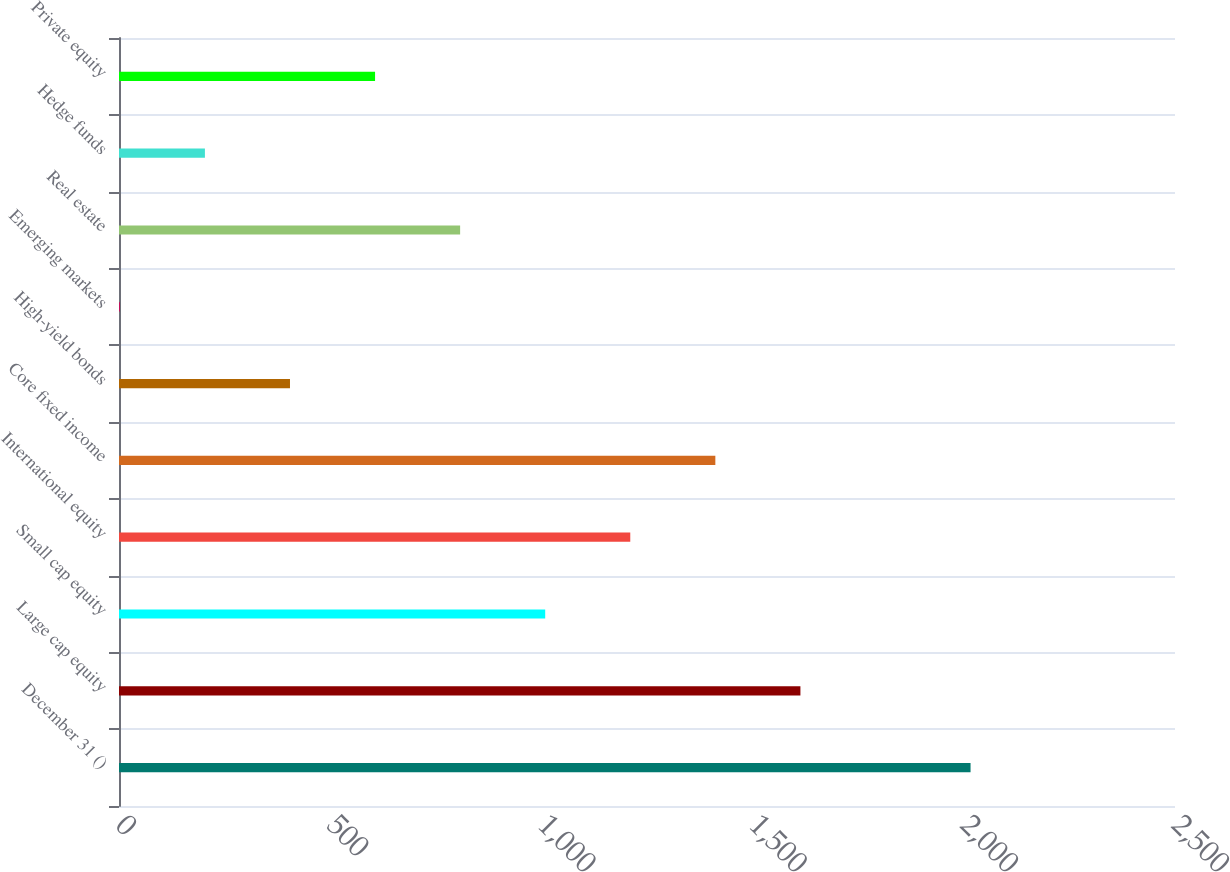Convert chart. <chart><loc_0><loc_0><loc_500><loc_500><bar_chart><fcel>December 31 ()<fcel>Large cap equity<fcel>Small cap equity<fcel>International equity<fcel>Core fixed income<fcel>High-yield bonds<fcel>Emerging markets<fcel>Real estate<fcel>Hedge funds<fcel>Private equity<nl><fcel>2016<fcel>1613.2<fcel>1009<fcel>1210.4<fcel>1411.8<fcel>404.8<fcel>2<fcel>807.6<fcel>203.4<fcel>606.2<nl></chart> 